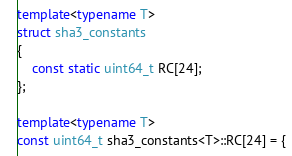Convert code to text. <code><loc_0><loc_0><loc_500><loc_500><_C++_>
template<typename T>
struct sha3_constants
{
	const static uint64_t RC[24];
};

template<typename T>
const uint64_t sha3_constants<T>::RC[24] = {</code> 